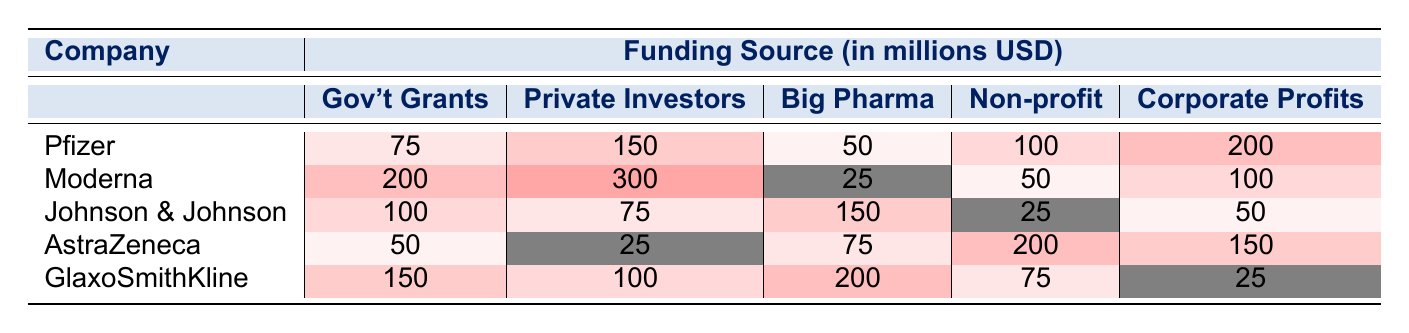What is the total amount of funding from government grants for Pfizer? The funding from government grants for Pfizer is listed as 75 million USD in the table.
Answer: 75 million USD Which company received the highest funding from private investors? The highest funding from private investors is shown as 300 million USD for Moderna.
Answer: Moderna What is the difference in funding between AstraZeneca's corporate profits and Johnson & Johnson's corporate profits? AstraZeneca's corporate profits are 150 million USD and Johnson & Johnson's are 50 million USD. The difference is 150 - 50 = 100 million USD.
Answer: 100 million USD Which funding source contributed the least to Moderna's total funding? Moderna received the least from Big Pharma with only 25 million USD, compared to other funding sources.
Answer: Big Pharma What is the sum of the funding received from non-profit organizations for all companies? The non-profit funding amounts are 100, 50, 25, 200, and 75 million USD. Summing these gives 100 + 50 + 25 + 200 + 75 = 450 million USD.
Answer: 450 million USD Did GlaxoSmithKline receive more funding from corporate profits than from government grants? GlaxoSmithKline received 25 million USD from corporate profits and 150 million USD from government grants, which means they received more from grants.
Answer: No Which company has the largest overall funding from all sources combined? To find the overall funding for each company, add all the funding amounts. Pfizer: 75 + 150 + 50 + 100 + 200 = 575 million USD, Moderna: 200 + 300 + 25 + 50 + 100 = 675 million USD, Johnson & Johnson: 100 + 75 + 150 + 25 + 50 = 400 million USD, AstraZeneca: 50 + 25 + 75 + 200 + 150 = 500 million USD, GlaxoSmithKline: 150 + 100 + 200 + 75 + 25 = 550 million USD. Moderna has the highest total of 675 million USD.
Answer: Moderna What percentage of Pfizer's total funding comes from private investors? First, calculate Pfizer's total funding: 75 + 150 + 50 + 100 + 200 = 575 million USD. Private investors contributed 150 million USD. The percentage is (150 / 575) * 100 ≈ 26.09%.
Answer: 26.09% Is the total funding from corporate profits across all companies greater than 500 million USD? Sum the corporate profits: 200 (Pfizer) + 100 (Moderna) + 50 (Johnson & Johnson) + 150 (AstraZeneca) + 25 (GlaxoSmithKline) = 625 million USD, which is greater than 500 million USD.
Answer: Yes What can be inferred about the reliance on government grants between AstraZeneca and Pfizer? AstraZeneca received only 50 million USD while Pfizer received 75 million USD, indicating that Pfizer is slightly more reliant on government grants than AstraZeneca.
Answer: Pfizer relies more on government grants 